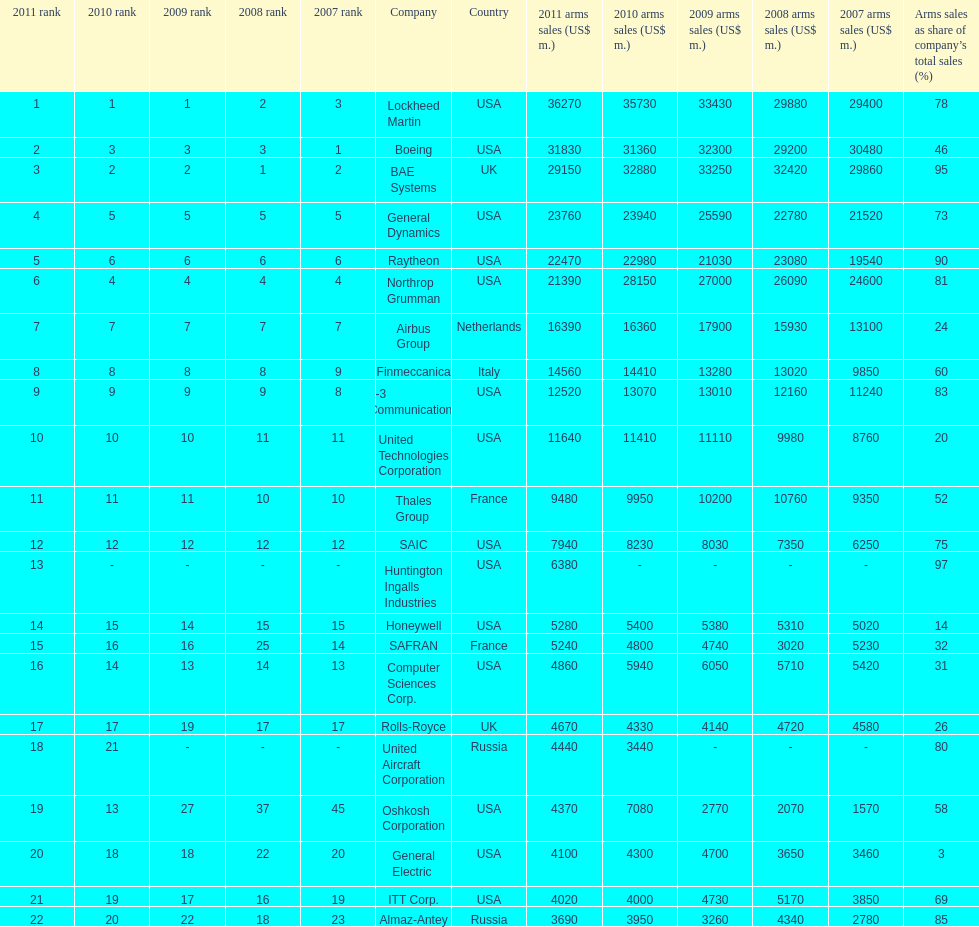Which company had the highest 2009 arms sales? Lockheed Martin. 